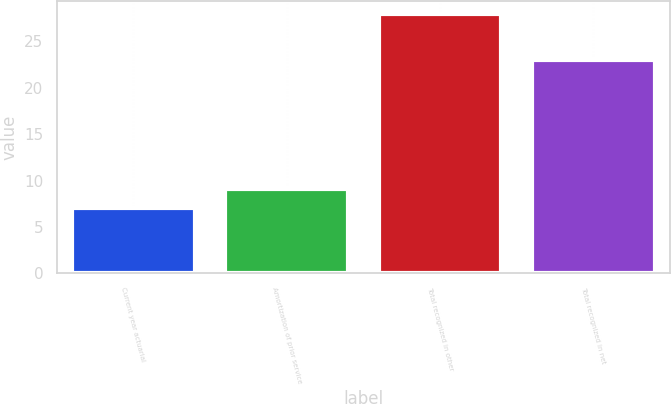Convert chart. <chart><loc_0><loc_0><loc_500><loc_500><bar_chart><fcel>Current year actuarial<fcel>Amortization of prior service<fcel>Total recognized in other<fcel>Total recognized in net<nl><fcel>7<fcel>9.1<fcel>28<fcel>23<nl></chart> 